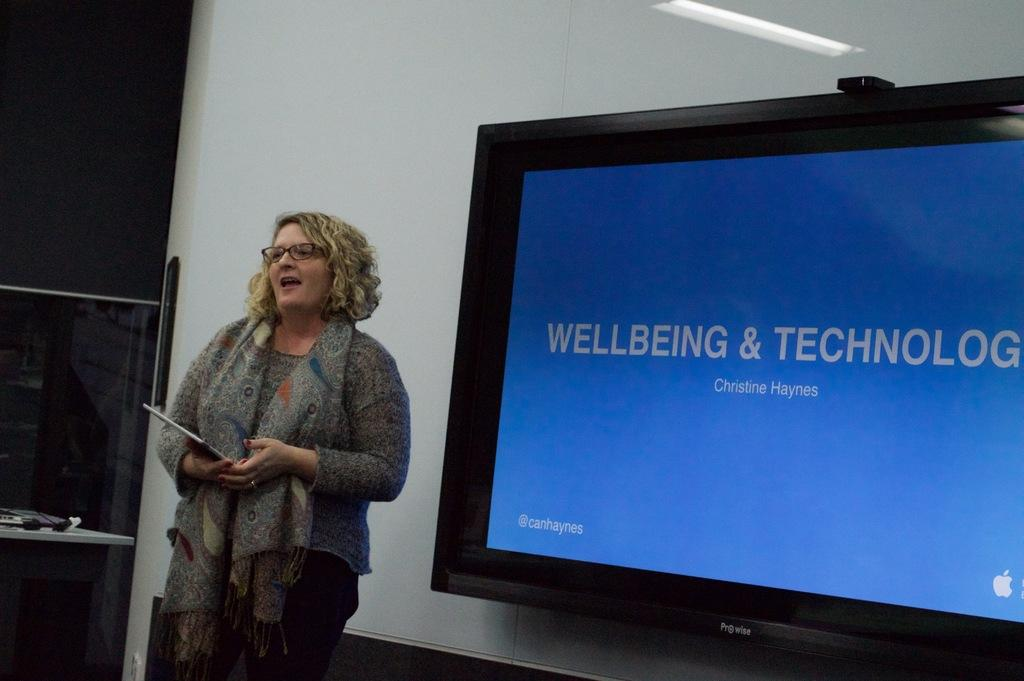Who is present in the image? There is a woman in the image. What is the woman doing in the image? The woman is holding an object and standing. What can be seen on the wall in the image? There is a television screen on the wall in the image. What is the main structure in the image? There is a wall in the image. What is located near the wall in the image? There is a table in the image. What is on the table in the image? There are objects on the table in the image. How many kittens are playing on the channel in the image? There are no kittens or channels present in the image. What type of tank is visible in the image? There is no tank present in the image. 